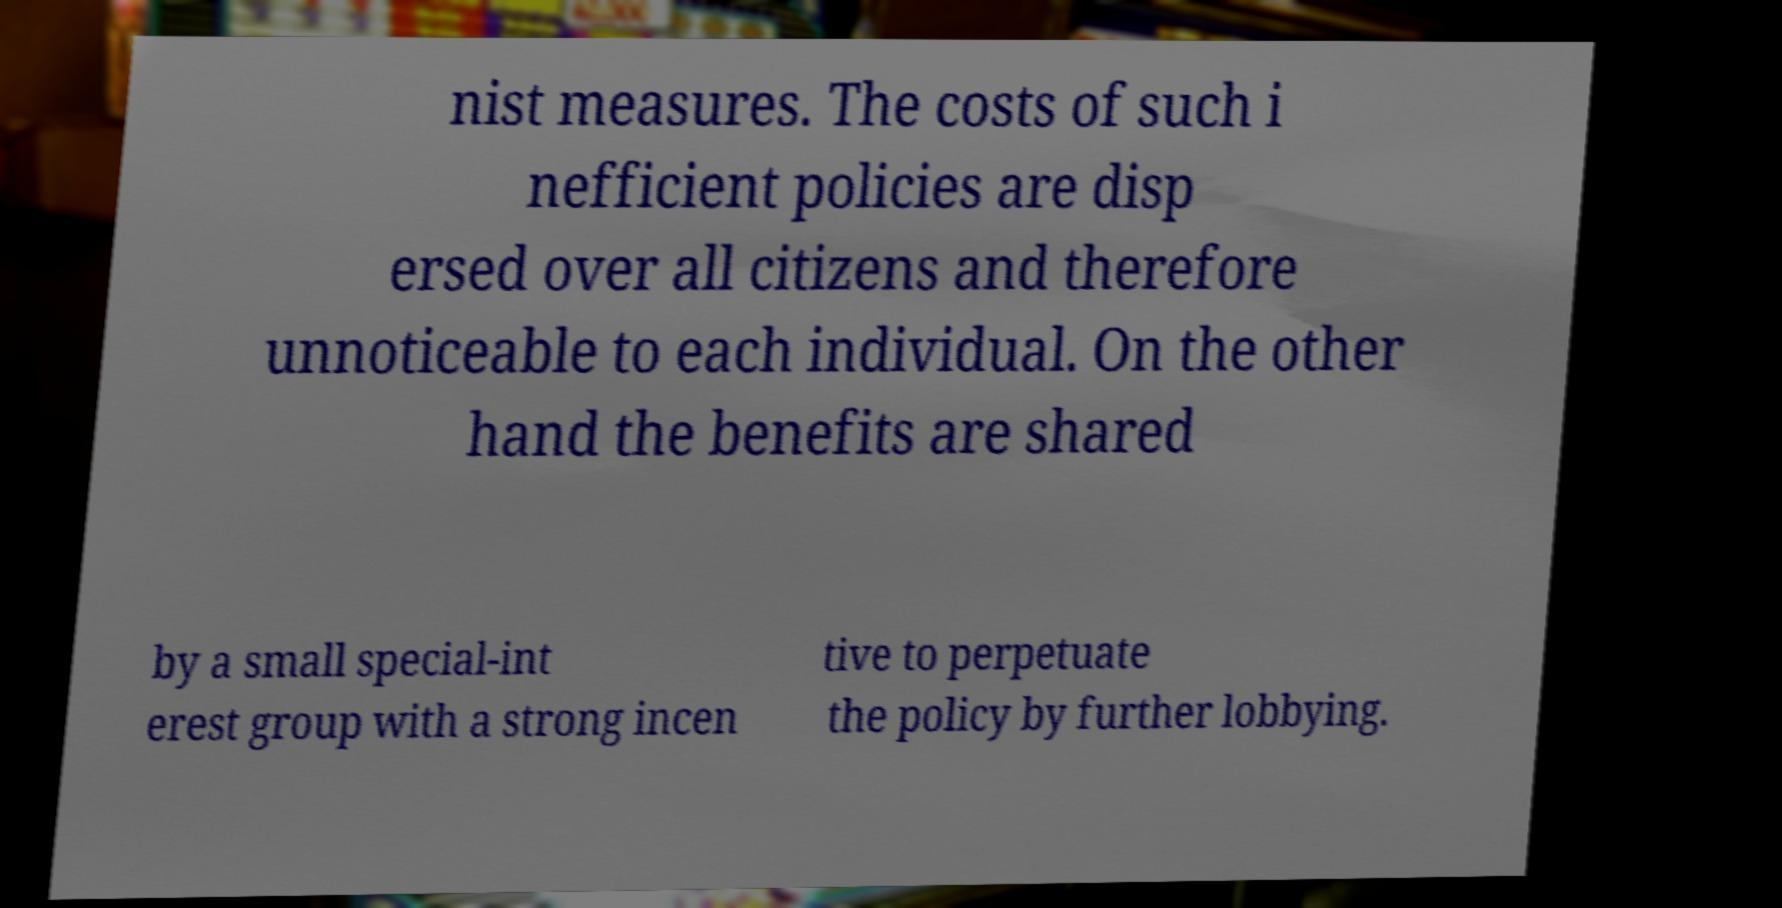Can you accurately transcribe the text from the provided image for me? nist measures. The costs of such i nefficient policies are disp ersed over all citizens and therefore unnoticeable to each individual. On the other hand the benefits are shared by a small special-int erest group with a strong incen tive to perpetuate the policy by further lobbying. 